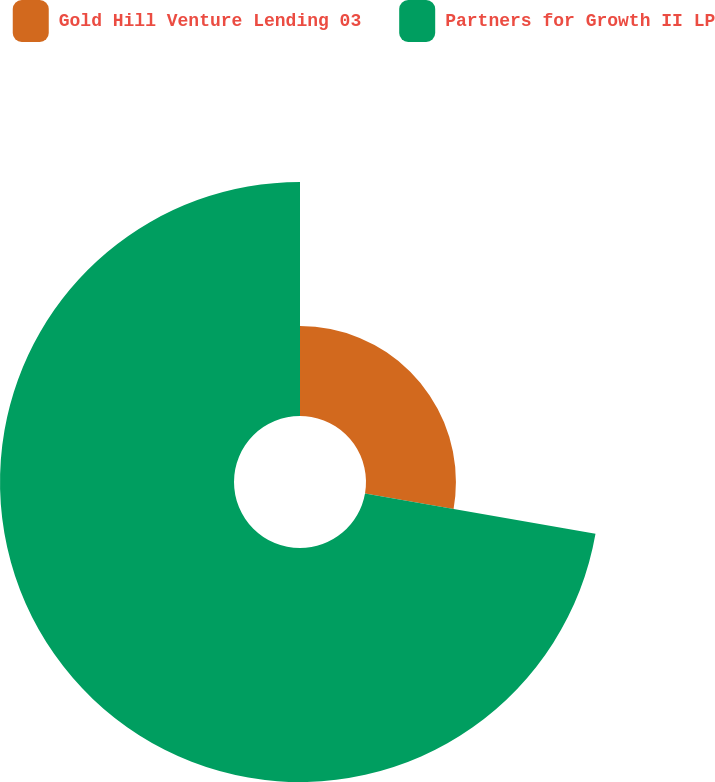Convert chart to OTSL. <chart><loc_0><loc_0><loc_500><loc_500><pie_chart><fcel>Gold Hill Venture Lending 03<fcel>Partners for Growth II LP<nl><fcel>27.76%<fcel>72.24%<nl></chart> 